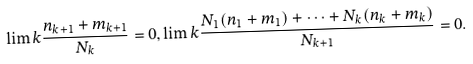<formula> <loc_0><loc_0><loc_500><loc_500>\lim k \frac { n _ { k + 1 } + m _ { k + 1 } } { N _ { k } } = 0 , \lim k \frac { N _ { 1 } ( n _ { 1 } + m _ { 1 } ) + \dots + N _ { k } ( n _ { k } + m _ { k } ) } { N _ { k + 1 } } = 0 .</formula> 